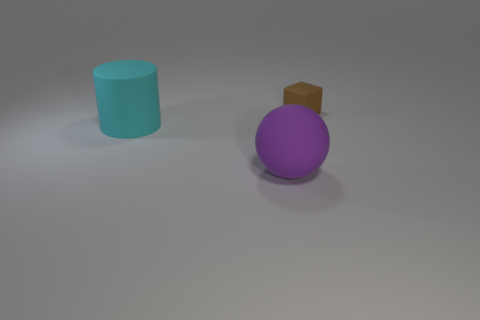What number of large objects are either cylinders or purple matte spheres?
Keep it short and to the point. 2. Does the thing behind the cyan thing have the same material as the object that is in front of the big cyan object?
Offer a terse response. Yes. Are any matte cylinders visible?
Offer a very short reply. Yes. Are there more purple rubber things behind the tiny brown rubber cube than balls that are on the left side of the ball?
Your answer should be very brief. No. Are there any other things that are the same size as the cyan rubber object?
Your answer should be compact. Yes. Do the object that is left of the large purple sphere and the large matte object on the right side of the cylinder have the same color?
Offer a very short reply. No. What shape is the large cyan matte object?
Keep it short and to the point. Cylinder. Are there more big rubber things to the right of the small cube than large green shiny blocks?
Offer a terse response. No. The rubber object to the left of the purple rubber object has what shape?
Ensure brevity in your answer.  Cylinder. How many other things are the same shape as the purple object?
Your answer should be compact. 0. 